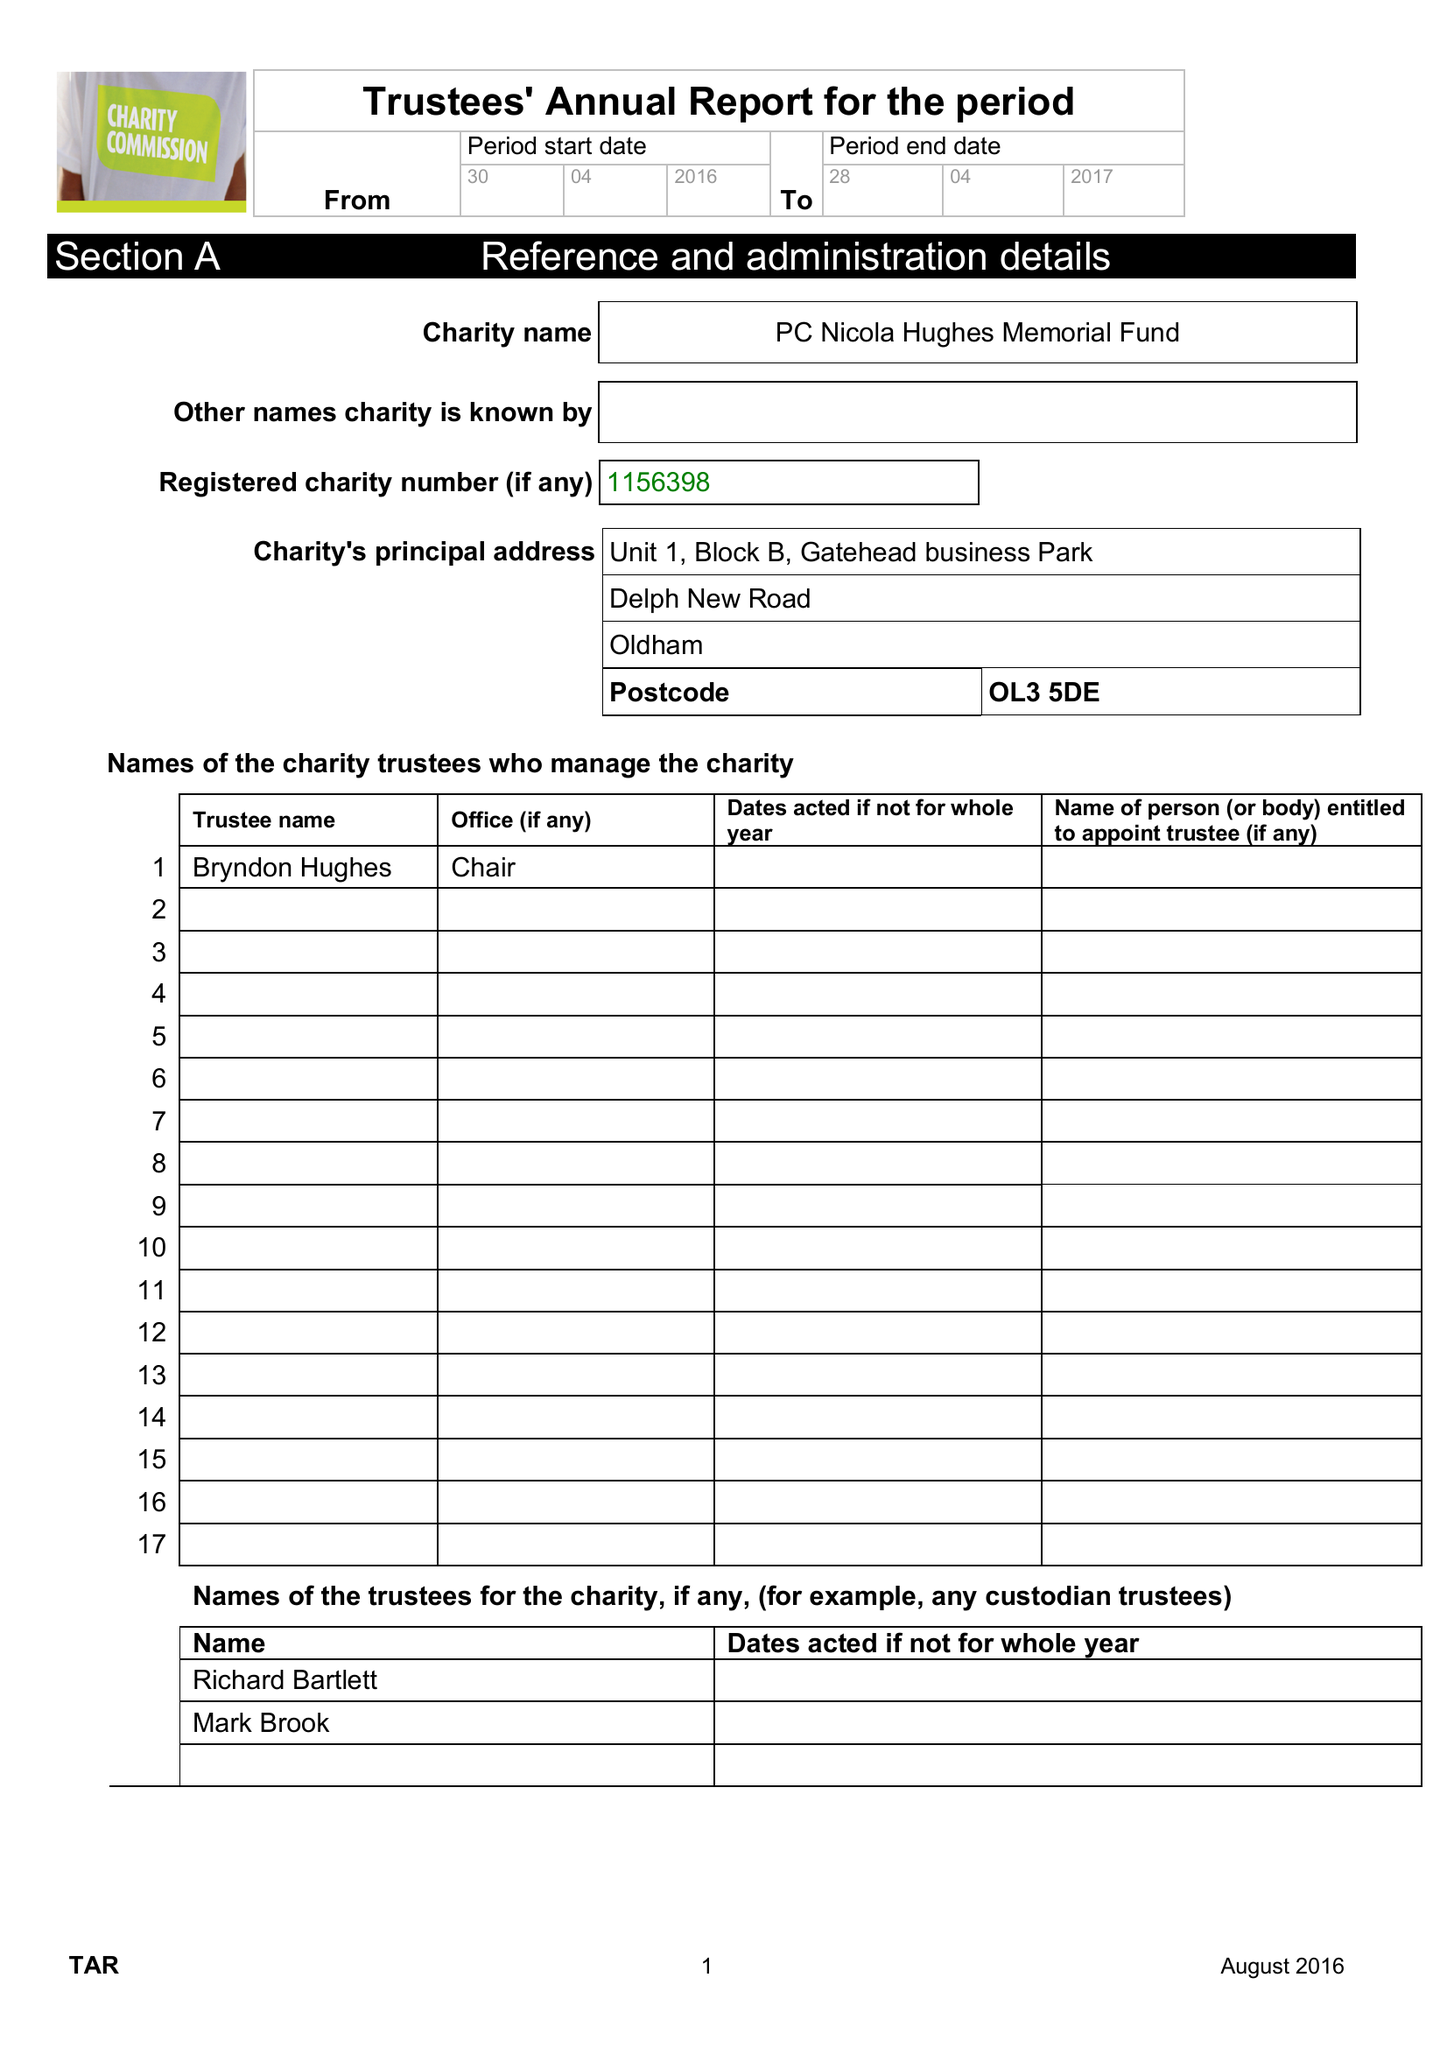What is the value for the address__post_town?
Answer the question using a single word or phrase. OLDHAM 